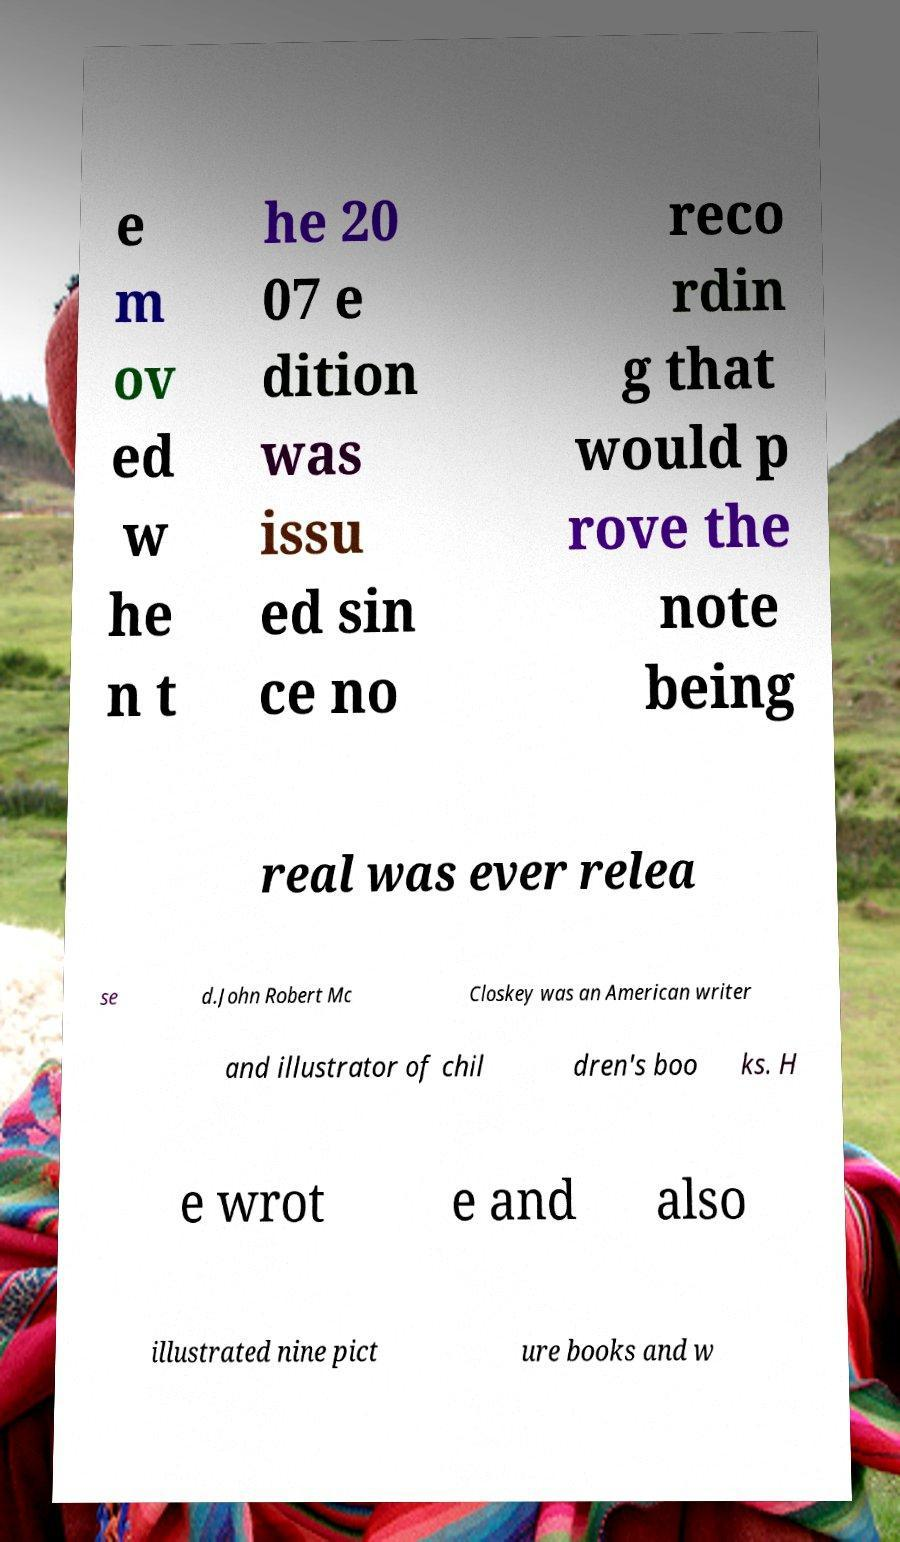Could you assist in decoding the text presented in this image and type it out clearly? e m ov ed w he n t he 20 07 e dition was issu ed sin ce no reco rdin g that would p rove the note being real was ever relea se d.John Robert Mc Closkey was an American writer and illustrator of chil dren's boo ks. H e wrot e and also illustrated nine pict ure books and w 